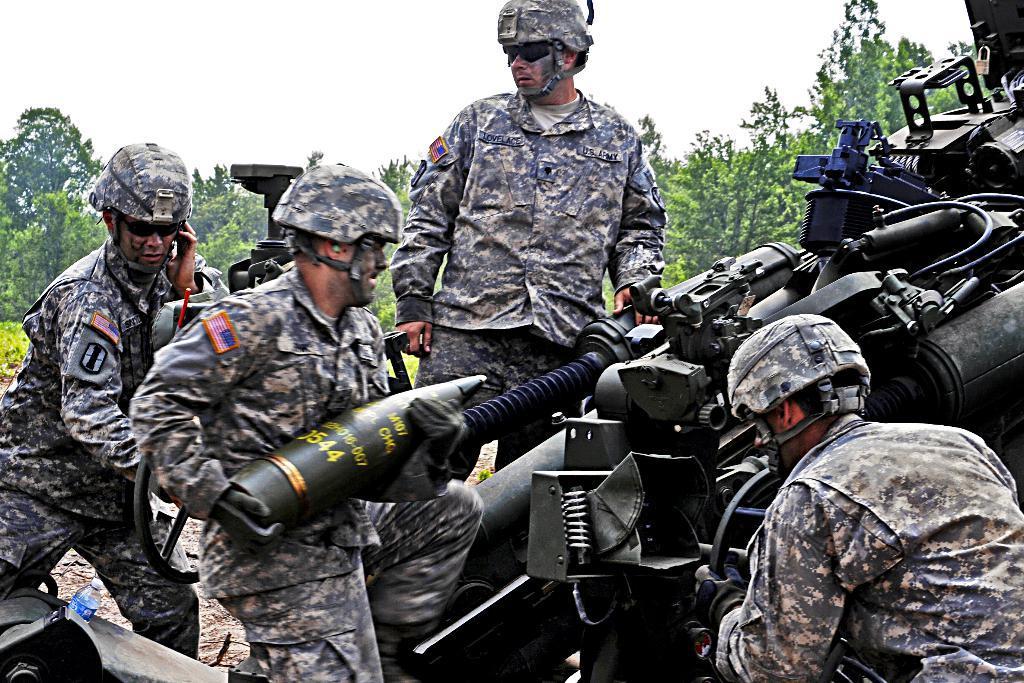In one or two sentences, can you explain what this image depicts? In the picture I can see four persons wearing army uniforms, helmets and glasses are standing. Here we can see a person on the right is operating a weapon and this person is holding an object in his hands and the person on the left side is talking on mobile phone. Here we can see a water bottle on the left side of the image and here we can see a weapon on the right side of the image. In the background, we can see the trees and the sky. 